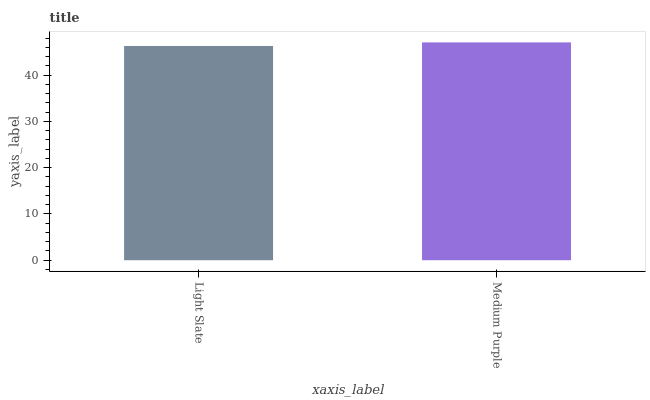Is Light Slate the minimum?
Answer yes or no. Yes. Is Medium Purple the maximum?
Answer yes or no. Yes. Is Medium Purple the minimum?
Answer yes or no. No. Is Medium Purple greater than Light Slate?
Answer yes or no. Yes. Is Light Slate less than Medium Purple?
Answer yes or no. Yes. Is Light Slate greater than Medium Purple?
Answer yes or no. No. Is Medium Purple less than Light Slate?
Answer yes or no. No. Is Medium Purple the high median?
Answer yes or no. Yes. Is Light Slate the low median?
Answer yes or no. Yes. Is Light Slate the high median?
Answer yes or no. No. Is Medium Purple the low median?
Answer yes or no. No. 